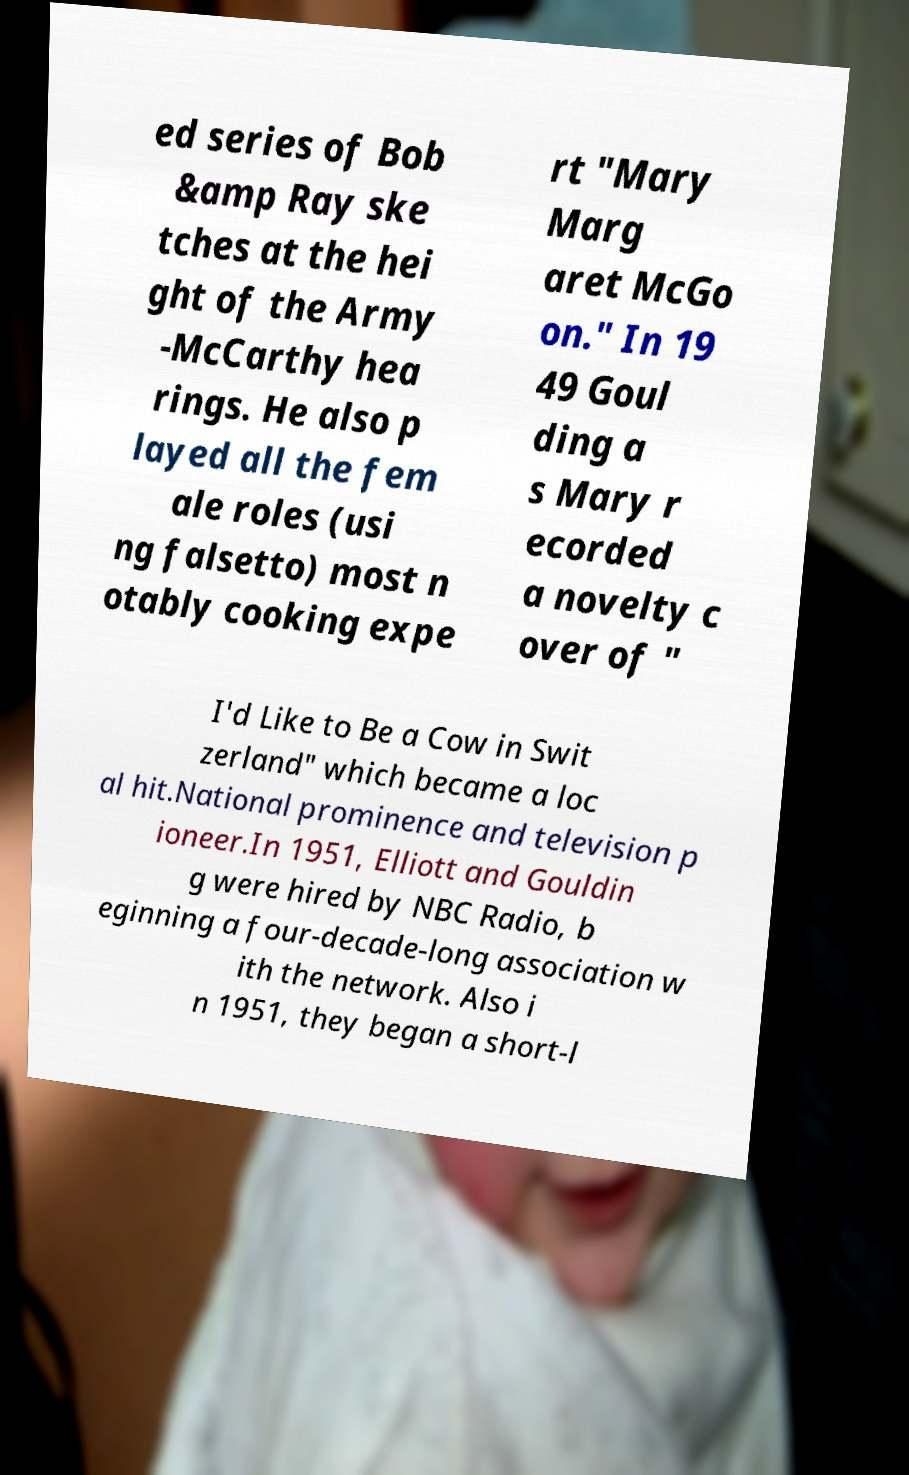Could you extract and type out the text from this image? ed series of Bob &amp Ray ske tches at the hei ght of the Army -McCarthy hea rings. He also p layed all the fem ale roles (usi ng falsetto) most n otably cooking expe rt "Mary Marg aret McGo on." In 19 49 Goul ding a s Mary r ecorded a novelty c over of " I'd Like to Be a Cow in Swit zerland" which became a loc al hit.National prominence and television p ioneer.In 1951, Elliott and Gouldin g were hired by NBC Radio, b eginning a four-decade-long association w ith the network. Also i n 1951, they began a short-l 